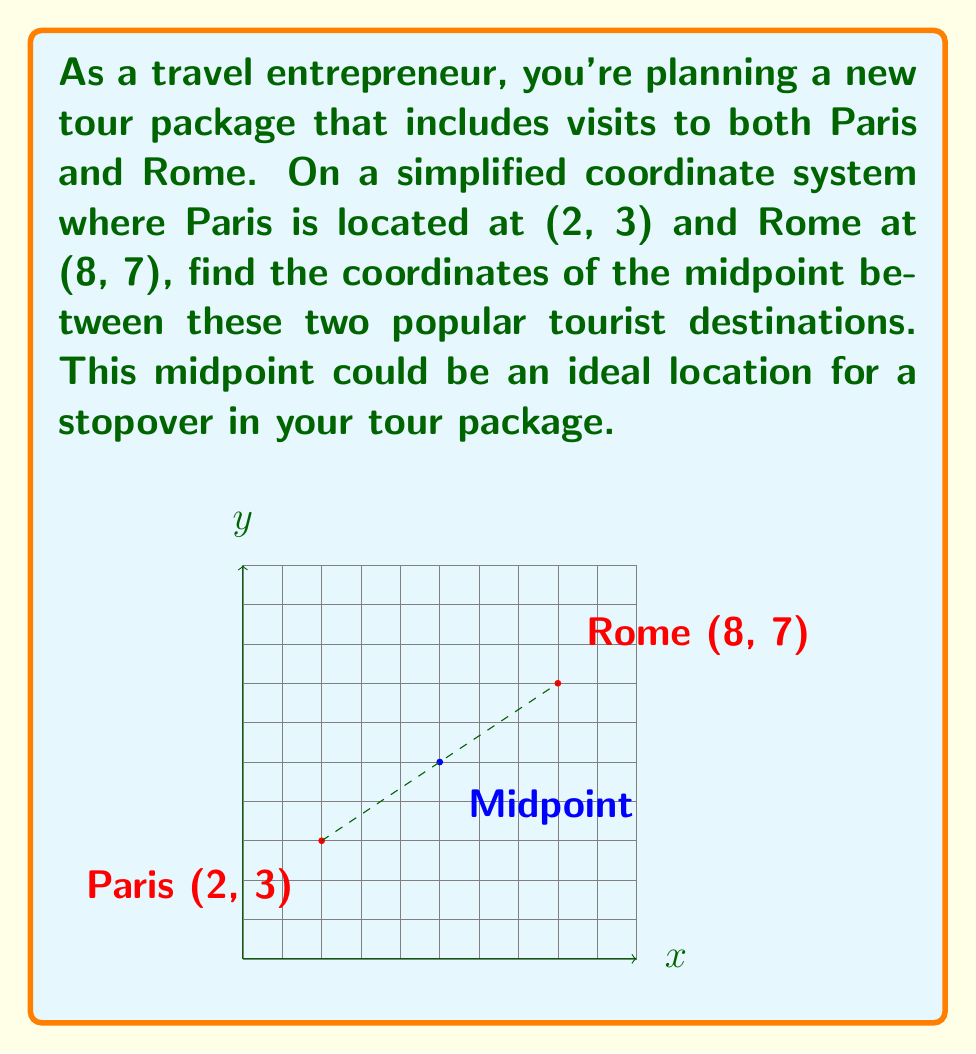Provide a solution to this math problem. To find the midpoint between two points, we use the midpoint formula:

$$ \text{Midpoint} = \left(\frac{x_1 + x_2}{2}, \frac{y_1 + y_2}{2}\right) $$

Where $(x_1, y_1)$ are the coordinates of the first point (Paris) and $(x_2, y_2)$ are the coordinates of the second point (Rome).

Step 1: Identify the coordinates
Paris: $(x_1, y_1) = (2, 3)$
Rome: $(x_2, y_2) = (8, 7)$

Step 2: Apply the midpoint formula
For the x-coordinate:
$$ x = \frac{x_1 + x_2}{2} = \frac{2 + 8}{2} = \frac{10}{2} = 5 $$

For the y-coordinate:
$$ y = \frac{y_1 + y_2}{2} = \frac{3 + 7}{2} = \frac{10}{2} = 5 $$

Step 3: Combine the results
The midpoint coordinates are $(5, 5)$
Answer: $(5, 5)$ 